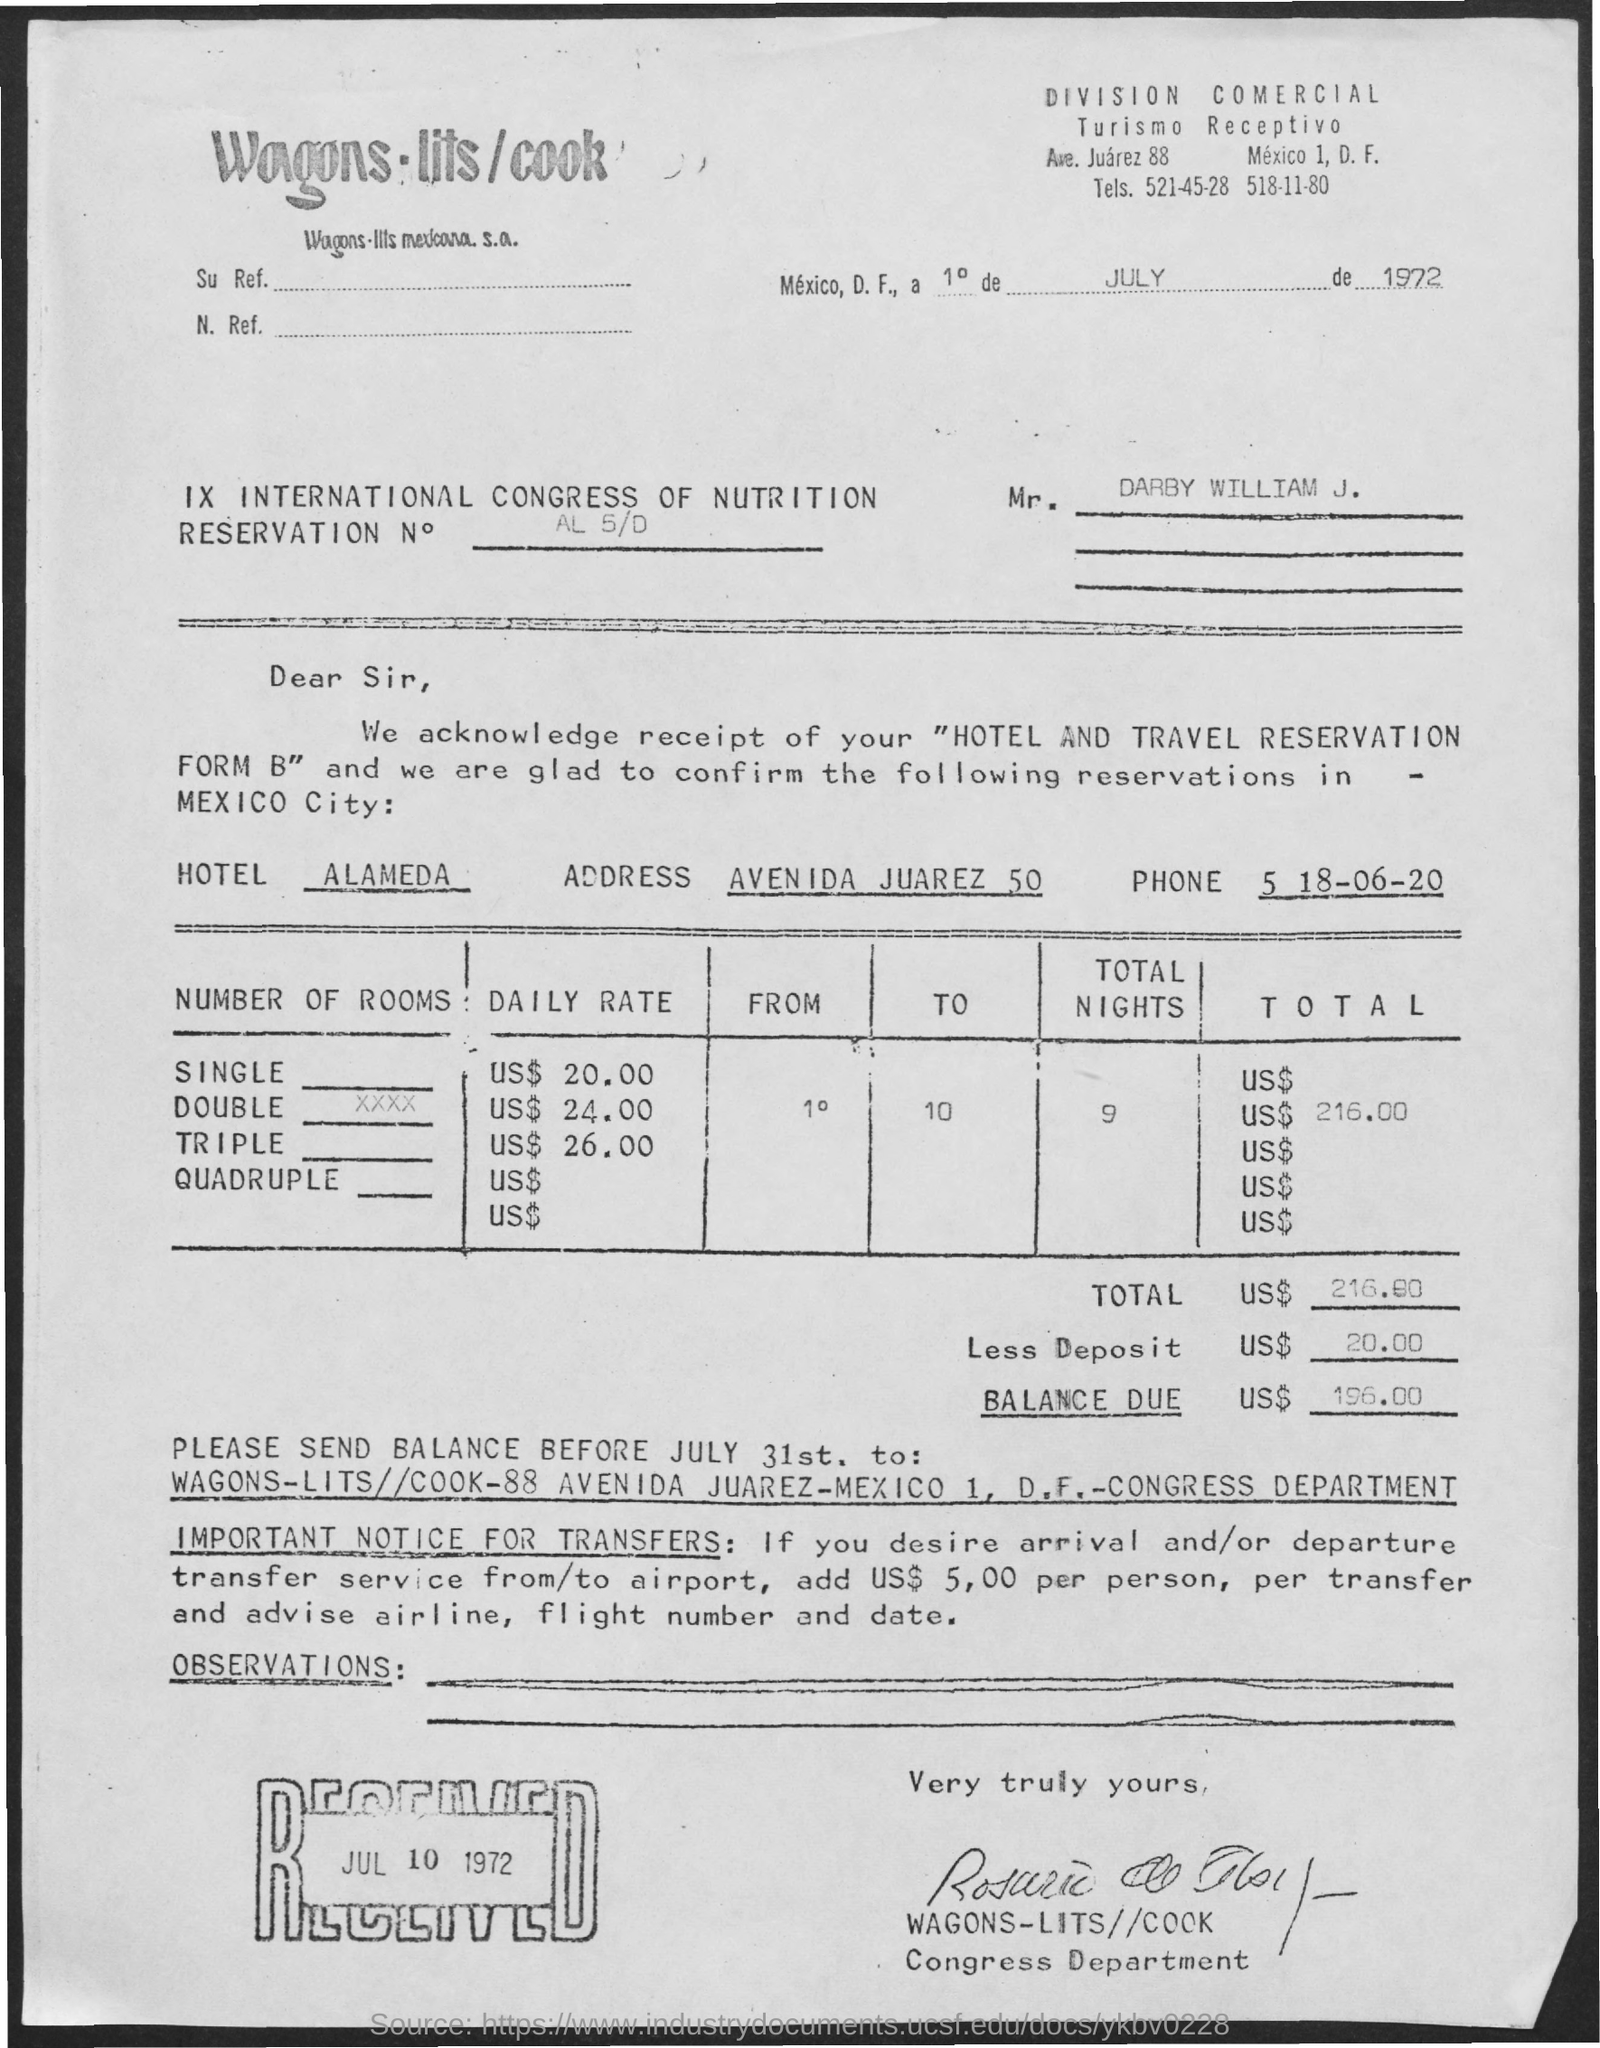Indicate a few pertinent items in this graphic. The name of the hotel is Alameda. 